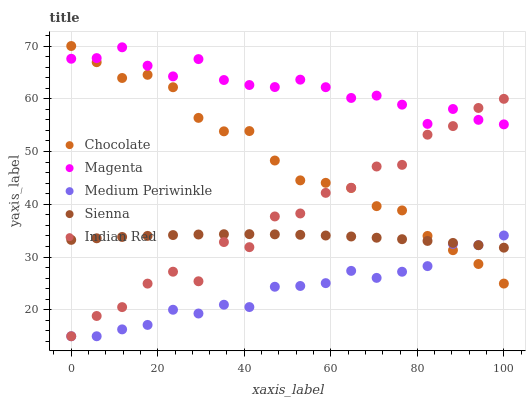Does Medium Periwinkle have the minimum area under the curve?
Answer yes or no. Yes. Does Magenta have the maximum area under the curve?
Answer yes or no. Yes. Does Magenta have the minimum area under the curve?
Answer yes or no. No. Does Medium Periwinkle have the maximum area under the curve?
Answer yes or no. No. Is Sienna the smoothest?
Answer yes or no. Yes. Is Indian Red the roughest?
Answer yes or no. Yes. Is Magenta the smoothest?
Answer yes or no. No. Is Magenta the roughest?
Answer yes or no. No. Does Medium Periwinkle have the lowest value?
Answer yes or no. Yes. Does Magenta have the lowest value?
Answer yes or no. No. Does Chocolate have the highest value?
Answer yes or no. Yes. Does Magenta have the highest value?
Answer yes or no. No. Is Medium Periwinkle less than Magenta?
Answer yes or no. Yes. Is Magenta greater than Sienna?
Answer yes or no. Yes. Does Magenta intersect Chocolate?
Answer yes or no. Yes. Is Magenta less than Chocolate?
Answer yes or no. No. Is Magenta greater than Chocolate?
Answer yes or no. No. Does Medium Periwinkle intersect Magenta?
Answer yes or no. No. 